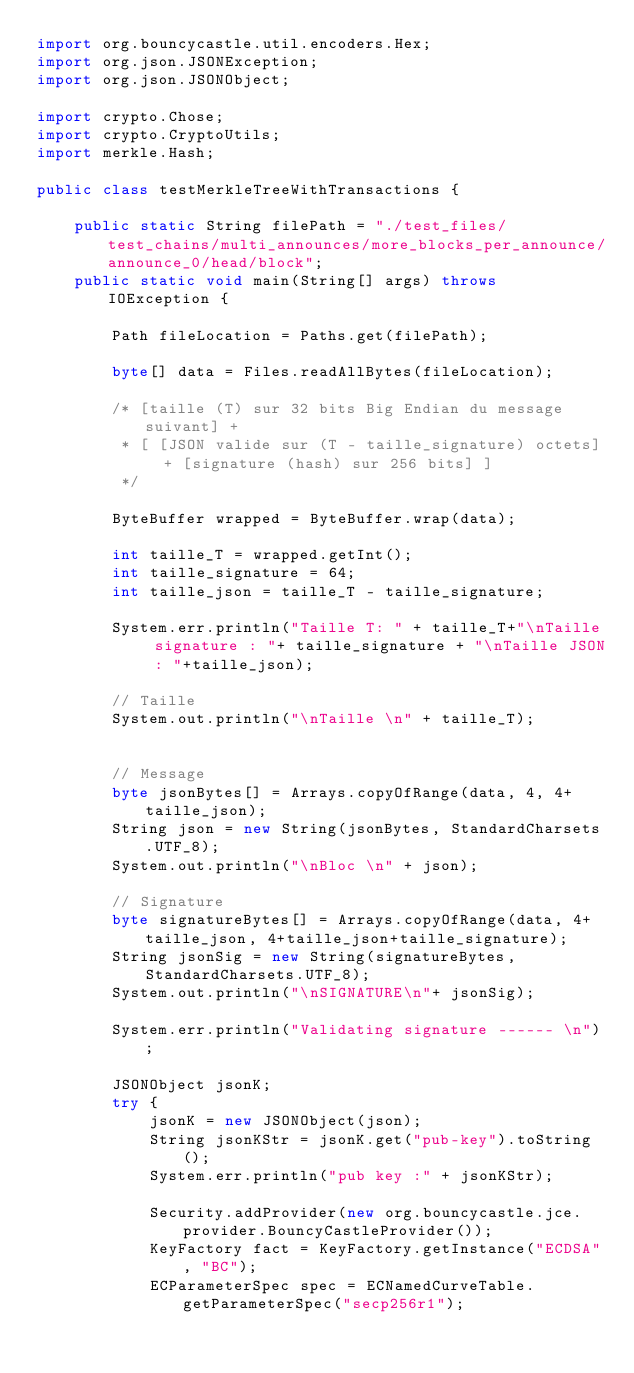<code> <loc_0><loc_0><loc_500><loc_500><_Java_>import org.bouncycastle.util.encoders.Hex;
import org.json.JSONException;
import org.json.JSONObject;

import crypto.Chose;
import crypto.CryptoUtils;
import merkle.Hash;

public class testMerkleTreeWithTransactions {

	public static String filePath = "./test_files/test_chains/multi_announces/more_blocks_per_announce/announce_0/head/block";
	public static void main(String[] args) throws IOException {

		Path fileLocation = Paths.get(filePath);

		byte[] data = Files.readAllBytes(fileLocation);

		/* [taille (T) sur 32 bits Big Endian du message suivant] +
		 * [ [JSON valide sur (T - taille_signature) octets] + [signature (hash) sur 256 bits] ]
		 */

		ByteBuffer wrapped = ByteBuffer.wrap(data);

		int taille_T = wrapped.getInt();
		int taille_signature = 64;
		int taille_json = taille_T - taille_signature;

		System.err.println("Taille T: " + taille_T+"\nTaille signature : "+ taille_signature + "\nTaille JSON : "+taille_json);

		// Taille
		System.out.println("\nTaille \n" + taille_T);


		// Message
		byte jsonBytes[] = Arrays.copyOfRange(data, 4, 4+taille_json);
		String json = new String(jsonBytes, StandardCharsets.UTF_8);
		System.out.println("\nBloc \n" + json);

		// Signature
		byte signatureBytes[] = Arrays.copyOfRange(data, 4+taille_json, 4+taille_json+taille_signature);
		String jsonSig = new String(signatureBytes, StandardCharsets.UTF_8);
		System.out.println("\nSIGNATURE\n"+ jsonSig);

		System.err.println("Validating signature ------ \n");

		JSONObject jsonK;
		try {
			jsonK = new JSONObject(json);
			String jsonKStr = jsonK.get("pub-key").toString();
			System.err.println("pub key :" + jsonKStr);
			
			Security.addProvider(new org.bouncycastle.jce.provider.BouncyCastleProvider());
	        KeyFactory fact = KeyFactory.getInstance("ECDSA", "BC");
	        ECParameterSpec spec = ECNamedCurveTable.getParameterSpec("secp256r1");</code> 